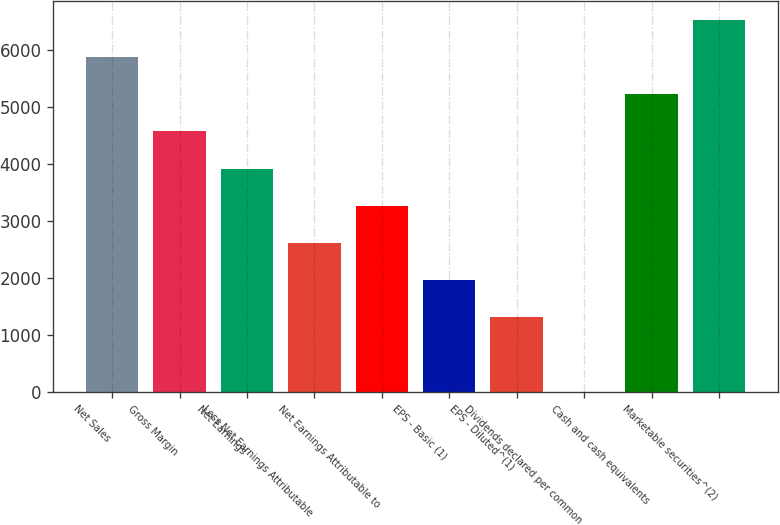<chart> <loc_0><loc_0><loc_500><loc_500><bar_chart><fcel>Net Sales<fcel>Gross Margin<fcel>Net Earnings<fcel>Less Net Earnings Attributable<fcel>Net Earnings Attributable to<fcel>EPS - Basic (1)<fcel>EPS - Diluted^(1)<fcel>Dividends declared per common<fcel>Cash and cash equivalents<fcel>Marketable securities^(2)<nl><fcel>5886.96<fcel>4578.82<fcel>3924.75<fcel>2616.61<fcel>3270.68<fcel>1962.54<fcel>1308.47<fcel>0.33<fcel>5232.89<fcel>6541.03<nl></chart> 